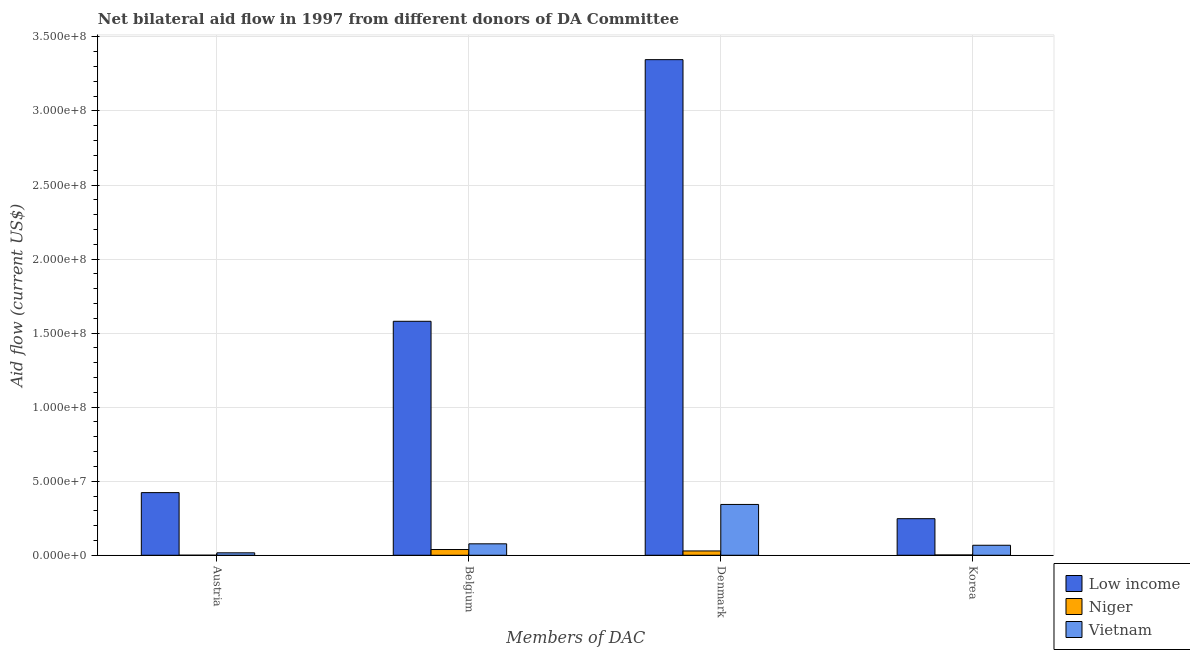How many different coloured bars are there?
Offer a terse response. 3. How many groups of bars are there?
Offer a very short reply. 4. How many bars are there on the 1st tick from the left?
Ensure brevity in your answer.  3. What is the amount of aid given by austria in Low income?
Your answer should be very brief. 4.23e+07. Across all countries, what is the maximum amount of aid given by belgium?
Make the answer very short. 1.58e+08. Across all countries, what is the minimum amount of aid given by denmark?
Make the answer very short. 2.91e+06. In which country was the amount of aid given by belgium minimum?
Make the answer very short. Niger. What is the total amount of aid given by denmark in the graph?
Offer a terse response. 3.72e+08. What is the difference between the amount of aid given by belgium in Niger and that in Low income?
Make the answer very short. -1.54e+08. What is the difference between the amount of aid given by korea in Vietnam and the amount of aid given by austria in Niger?
Your answer should be very brief. 6.72e+06. What is the average amount of aid given by korea per country?
Offer a terse response. 1.06e+07. What is the difference between the amount of aid given by belgium and amount of aid given by austria in Niger?
Give a very brief answer. 3.84e+06. What is the ratio of the amount of aid given by denmark in Niger to that in Low income?
Give a very brief answer. 0.01. What is the difference between the highest and the second highest amount of aid given by austria?
Your answer should be compact. 4.06e+07. What is the difference between the highest and the lowest amount of aid given by denmark?
Offer a very short reply. 3.32e+08. Is the sum of the amount of aid given by austria in Low income and Vietnam greater than the maximum amount of aid given by korea across all countries?
Ensure brevity in your answer.  Yes. What does the 2nd bar from the right in Austria represents?
Give a very brief answer. Niger. How many bars are there?
Offer a very short reply. 12. What is the difference between two consecutive major ticks on the Y-axis?
Provide a succinct answer. 5.00e+07. How many legend labels are there?
Provide a succinct answer. 3. How are the legend labels stacked?
Provide a short and direct response. Vertical. What is the title of the graph?
Offer a terse response. Net bilateral aid flow in 1997 from different donors of DA Committee. Does "Northern Mariana Islands" appear as one of the legend labels in the graph?
Provide a short and direct response. No. What is the label or title of the X-axis?
Provide a succinct answer. Members of DAC. What is the Aid flow (current US$) in Low income in Austria?
Keep it short and to the point. 4.23e+07. What is the Aid flow (current US$) in Vietnam in Austria?
Provide a succinct answer. 1.65e+06. What is the Aid flow (current US$) in Low income in Belgium?
Your answer should be compact. 1.58e+08. What is the Aid flow (current US$) in Niger in Belgium?
Ensure brevity in your answer.  3.87e+06. What is the Aid flow (current US$) of Vietnam in Belgium?
Give a very brief answer. 7.73e+06. What is the Aid flow (current US$) of Low income in Denmark?
Provide a succinct answer. 3.35e+08. What is the Aid flow (current US$) in Niger in Denmark?
Offer a very short reply. 2.91e+06. What is the Aid flow (current US$) of Vietnam in Denmark?
Provide a short and direct response. 3.43e+07. What is the Aid flow (current US$) in Low income in Korea?
Ensure brevity in your answer.  2.47e+07. What is the Aid flow (current US$) in Niger in Korea?
Provide a short and direct response. 2.10e+05. What is the Aid flow (current US$) of Vietnam in Korea?
Provide a short and direct response. 6.75e+06. Across all Members of DAC, what is the maximum Aid flow (current US$) in Low income?
Ensure brevity in your answer.  3.35e+08. Across all Members of DAC, what is the maximum Aid flow (current US$) in Niger?
Offer a terse response. 3.87e+06. Across all Members of DAC, what is the maximum Aid flow (current US$) in Vietnam?
Your answer should be compact. 3.43e+07. Across all Members of DAC, what is the minimum Aid flow (current US$) in Low income?
Offer a terse response. 2.47e+07. Across all Members of DAC, what is the minimum Aid flow (current US$) of Vietnam?
Your answer should be very brief. 1.65e+06. What is the total Aid flow (current US$) in Low income in the graph?
Provide a succinct answer. 5.60e+08. What is the total Aid flow (current US$) in Niger in the graph?
Keep it short and to the point. 7.02e+06. What is the total Aid flow (current US$) in Vietnam in the graph?
Your answer should be compact. 5.04e+07. What is the difference between the Aid flow (current US$) of Low income in Austria and that in Belgium?
Ensure brevity in your answer.  -1.16e+08. What is the difference between the Aid flow (current US$) of Niger in Austria and that in Belgium?
Offer a terse response. -3.84e+06. What is the difference between the Aid flow (current US$) of Vietnam in Austria and that in Belgium?
Offer a very short reply. -6.08e+06. What is the difference between the Aid flow (current US$) in Low income in Austria and that in Denmark?
Your answer should be very brief. -2.92e+08. What is the difference between the Aid flow (current US$) in Niger in Austria and that in Denmark?
Give a very brief answer. -2.88e+06. What is the difference between the Aid flow (current US$) in Vietnam in Austria and that in Denmark?
Make the answer very short. -3.27e+07. What is the difference between the Aid flow (current US$) in Low income in Austria and that in Korea?
Provide a short and direct response. 1.76e+07. What is the difference between the Aid flow (current US$) of Niger in Austria and that in Korea?
Provide a succinct answer. -1.80e+05. What is the difference between the Aid flow (current US$) in Vietnam in Austria and that in Korea?
Your answer should be compact. -5.10e+06. What is the difference between the Aid flow (current US$) in Low income in Belgium and that in Denmark?
Offer a terse response. -1.77e+08. What is the difference between the Aid flow (current US$) in Niger in Belgium and that in Denmark?
Give a very brief answer. 9.60e+05. What is the difference between the Aid flow (current US$) of Vietnam in Belgium and that in Denmark?
Your response must be concise. -2.66e+07. What is the difference between the Aid flow (current US$) of Low income in Belgium and that in Korea?
Ensure brevity in your answer.  1.33e+08. What is the difference between the Aid flow (current US$) in Niger in Belgium and that in Korea?
Your response must be concise. 3.66e+06. What is the difference between the Aid flow (current US$) of Vietnam in Belgium and that in Korea?
Give a very brief answer. 9.80e+05. What is the difference between the Aid flow (current US$) of Low income in Denmark and that in Korea?
Offer a terse response. 3.10e+08. What is the difference between the Aid flow (current US$) of Niger in Denmark and that in Korea?
Your answer should be compact. 2.70e+06. What is the difference between the Aid flow (current US$) in Vietnam in Denmark and that in Korea?
Your response must be concise. 2.76e+07. What is the difference between the Aid flow (current US$) of Low income in Austria and the Aid flow (current US$) of Niger in Belgium?
Make the answer very short. 3.84e+07. What is the difference between the Aid flow (current US$) in Low income in Austria and the Aid flow (current US$) in Vietnam in Belgium?
Provide a short and direct response. 3.46e+07. What is the difference between the Aid flow (current US$) in Niger in Austria and the Aid flow (current US$) in Vietnam in Belgium?
Make the answer very short. -7.70e+06. What is the difference between the Aid flow (current US$) of Low income in Austria and the Aid flow (current US$) of Niger in Denmark?
Keep it short and to the point. 3.94e+07. What is the difference between the Aid flow (current US$) of Low income in Austria and the Aid flow (current US$) of Vietnam in Denmark?
Provide a short and direct response. 7.99e+06. What is the difference between the Aid flow (current US$) in Niger in Austria and the Aid flow (current US$) in Vietnam in Denmark?
Give a very brief answer. -3.43e+07. What is the difference between the Aid flow (current US$) of Low income in Austria and the Aid flow (current US$) of Niger in Korea?
Give a very brief answer. 4.21e+07. What is the difference between the Aid flow (current US$) in Low income in Austria and the Aid flow (current US$) in Vietnam in Korea?
Offer a very short reply. 3.56e+07. What is the difference between the Aid flow (current US$) in Niger in Austria and the Aid flow (current US$) in Vietnam in Korea?
Your answer should be compact. -6.72e+06. What is the difference between the Aid flow (current US$) in Low income in Belgium and the Aid flow (current US$) in Niger in Denmark?
Your response must be concise. 1.55e+08. What is the difference between the Aid flow (current US$) in Low income in Belgium and the Aid flow (current US$) in Vietnam in Denmark?
Keep it short and to the point. 1.24e+08. What is the difference between the Aid flow (current US$) of Niger in Belgium and the Aid flow (current US$) of Vietnam in Denmark?
Provide a succinct answer. -3.04e+07. What is the difference between the Aid flow (current US$) of Low income in Belgium and the Aid flow (current US$) of Niger in Korea?
Your response must be concise. 1.58e+08. What is the difference between the Aid flow (current US$) of Low income in Belgium and the Aid flow (current US$) of Vietnam in Korea?
Make the answer very short. 1.51e+08. What is the difference between the Aid flow (current US$) of Niger in Belgium and the Aid flow (current US$) of Vietnam in Korea?
Make the answer very short. -2.88e+06. What is the difference between the Aid flow (current US$) in Low income in Denmark and the Aid flow (current US$) in Niger in Korea?
Ensure brevity in your answer.  3.34e+08. What is the difference between the Aid flow (current US$) in Low income in Denmark and the Aid flow (current US$) in Vietnam in Korea?
Provide a succinct answer. 3.28e+08. What is the difference between the Aid flow (current US$) in Niger in Denmark and the Aid flow (current US$) in Vietnam in Korea?
Your answer should be very brief. -3.84e+06. What is the average Aid flow (current US$) in Low income per Members of DAC?
Your answer should be compact. 1.40e+08. What is the average Aid flow (current US$) in Niger per Members of DAC?
Ensure brevity in your answer.  1.76e+06. What is the average Aid flow (current US$) of Vietnam per Members of DAC?
Offer a terse response. 1.26e+07. What is the difference between the Aid flow (current US$) of Low income and Aid flow (current US$) of Niger in Austria?
Offer a terse response. 4.23e+07. What is the difference between the Aid flow (current US$) in Low income and Aid flow (current US$) in Vietnam in Austria?
Ensure brevity in your answer.  4.06e+07. What is the difference between the Aid flow (current US$) in Niger and Aid flow (current US$) in Vietnam in Austria?
Give a very brief answer. -1.62e+06. What is the difference between the Aid flow (current US$) in Low income and Aid flow (current US$) in Niger in Belgium?
Provide a succinct answer. 1.54e+08. What is the difference between the Aid flow (current US$) of Low income and Aid flow (current US$) of Vietnam in Belgium?
Offer a very short reply. 1.50e+08. What is the difference between the Aid flow (current US$) of Niger and Aid flow (current US$) of Vietnam in Belgium?
Provide a short and direct response. -3.86e+06. What is the difference between the Aid flow (current US$) in Low income and Aid flow (current US$) in Niger in Denmark?
Your response must be concise. 3.32e+08. What is the difference between the Aid flow (current US$) in Low income and Aid flow (current US$) in Vietnam in Denmark?
Keep it short and to the point. 3.00e+08. What is the difference between the Aid flow (current US$) in Niger and Aid flow (current US$) in Vietnam in Denmark?
Give a very brief answer. -3.14e+07. What is the difference between the Aid flow (current US$) of Low income and Aid flow (current US$) of Niger in Korea?
Offer a very short reply. 2.45e+07. What is the difference between the Aid flow (current US$) of Low income and Aid flow (current US$) of Vietnam in Korea?
Your response must be concise. 1.80e+07. What is the difference between the Aid flow (current US$) in Niger and Aid flow (current US$) in Vietnam in Korea?
Offer a very short reply. -6.54e+06. What is the ratio of the Aid flow (current US$) of Low income in Austria to that in Belgium?
Make the answer very short. 0.27. What is the ratio of the Aid flow (current US$) of Niger in Austria to that in Belgium?
Make the answer very short. 0.01. What is the ratio of the Aid flow (current US$) in Vietnam in Austria to that in Belgium?
Give a very brief answer. 0.21. What is the ratio of the Aid flow (current US$) of Low income in Austria to that in Denmark?
Offer a terse response. 0.13. What is the ratio of the Aid flow (current US$) in Niger in Austria to that in Denmark?
Offer a very short reply. 0.01. What is the ratio of the Aid flow (current US$) in Vietnam in Austria to that in Denmark?
Ensure brevity in your answer.  0.05. What is the ratio of the Aid flow (current US$) in Low income in Austria to that in Korea?
Your answer should be very brief. 1.71. What is the ratio of the Aid flow (current US$) of Niger in Austria to that in Korea?
Offer a terse response. 0.14. What is the ratio of the Aid flow (current US$) of Vietnam in Austria to that in Korea?
Your answer should be compact. 0.24. What is the ratio of the Aid flow (current US$) of Low income in Belgium to that in Denmark?
Your answer should be very brief. 0.47. What is the ratio of the Aid flow (current US$) of Niger in Belgium to that in Denmark?
Make the answer very short. 1.33. What is the ratio of the Aid flow (current US$) in Vietnam in Belgium to that in Denmark?
Provide a succinct answer. 0.23. What is the ratio of the Aid flow (current US$) of Low income in Belgium to that in Korea?
Your response must be concise. 6.4. What is the ratio of the Aid flow (current US$) of Niger in Belgium to that in Korea?
Make the answer very short. 18.43. What is the ratio of the Aid flow (current US$) in Vietnam in Belgium to that in Korea?
Provide a succinct answer. 1.15. What is the ratio of the Aid flow (current US$) of Low income in Denmark to that in Korea?
Keep it short and to the point. 13.55. What is the ratio of the Aid flow (current US$) of Niger in Denmark to that in Korea?
Your answer should be very brief. 13.86. What is the ratio of the Aid flow (current US$) in Vietnam in Denmark to that in Korea?
Offer a very short reply. 5.08. What is the difference between the highest and the second highest Aid flow (current US$) of Low income?
Make the answer very short. 1.77e+08. What is the difference between the highest and the second highest Aid flow (current US$) in Niger?
Your answer should be compact. 9.60e+05. What is the difference between the highest and the second highest Aid flow (current US$) of Vietnam?
Provide a succinct answer. 2.66e+07. What is the difference between the highest and the lowest Aid flow (current US$) of Low income?
Offer a terse response. 3.10e+08. What is the difference between the highest and the lowest Aid flow (current US$) in Niger?
Ensure brevity in your answer.  3.84e+06. What is the difference between the highest and the lowest Aid flow (current US$) in Vietnam?
Your response must be concise. 3.27e+07. 